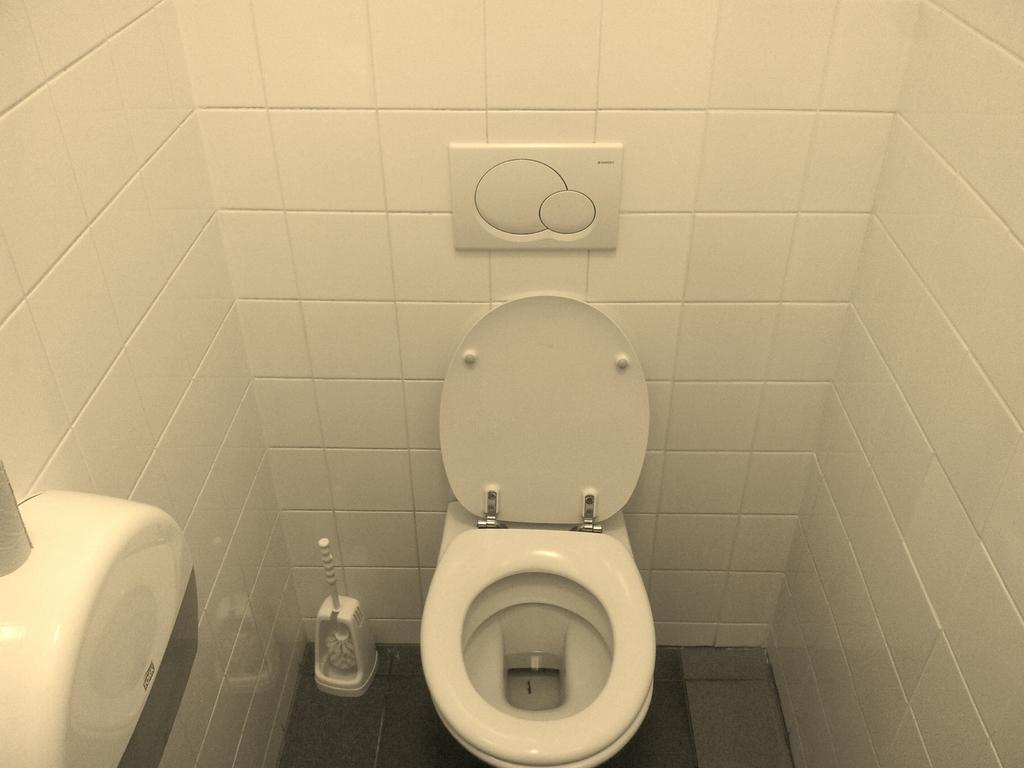What type of toilet is visible in the image? There is a western toilet in the image. What is located behind the toilet in the image? There is a wall behind the toilet in the image. What type of trade is being conducted in the image? There is no trade being conducted in the image; it only features a western toilet and a wall. Can you see a key or a crate in the image? No, there is no key or crate present in the image. 